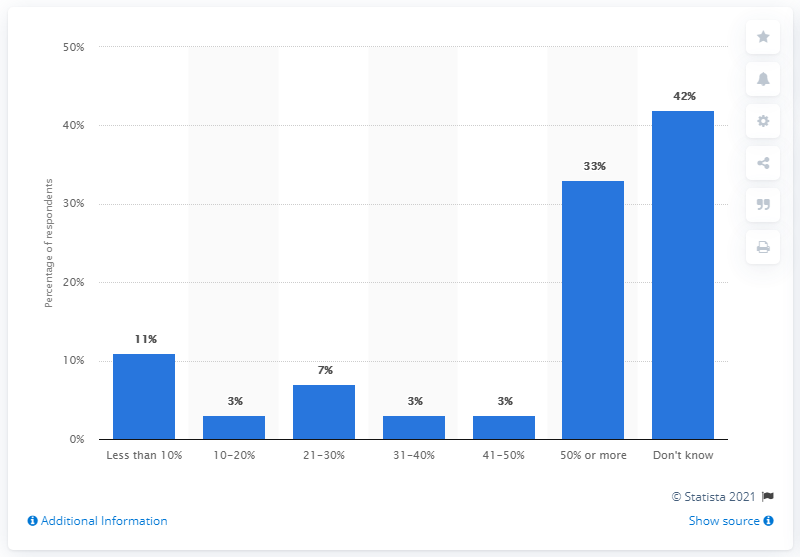Highlight a few significant elements in this photo. The percentage value of blue bars under 50% is 27. The leading response in the chart is 'Don't know.' 